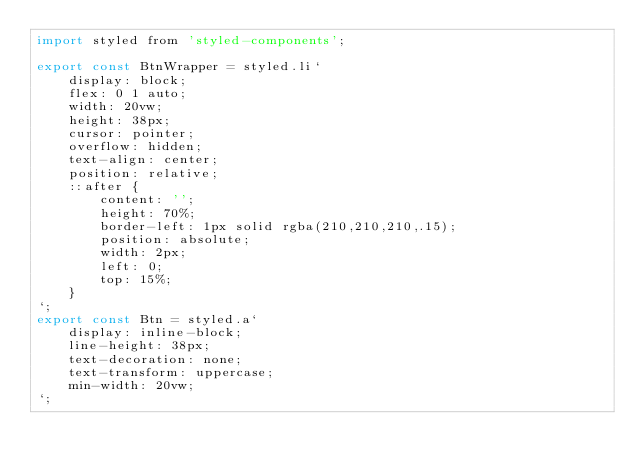Convert code to text. <code><loc_0><loc_0><loc_500><loc_500><_JavaScript_>import styled from 'styled-components';

export const BtnWrapper = styled.li`
	display: block;
	flex: 0 1 auto;
	width: 20vw;
	height: 38px;
	cursor: pointer;
	overflow: hidden;
	text-align: center;
	position: relative;
	::after {
		content: '';
		height: 70%;
		border-left: 1px solid rgba(210,210,210,.15);
		position: absolute;
		width: 2px;
		left: 0;
		top: 15%;
	}
`;
export const Btn = styled.a`
	display: inline-block;
	line-height: 38px;
	text-decoration: none;
	text-transform: uppercase;
	min-width: 20vw;
`;
</code> 